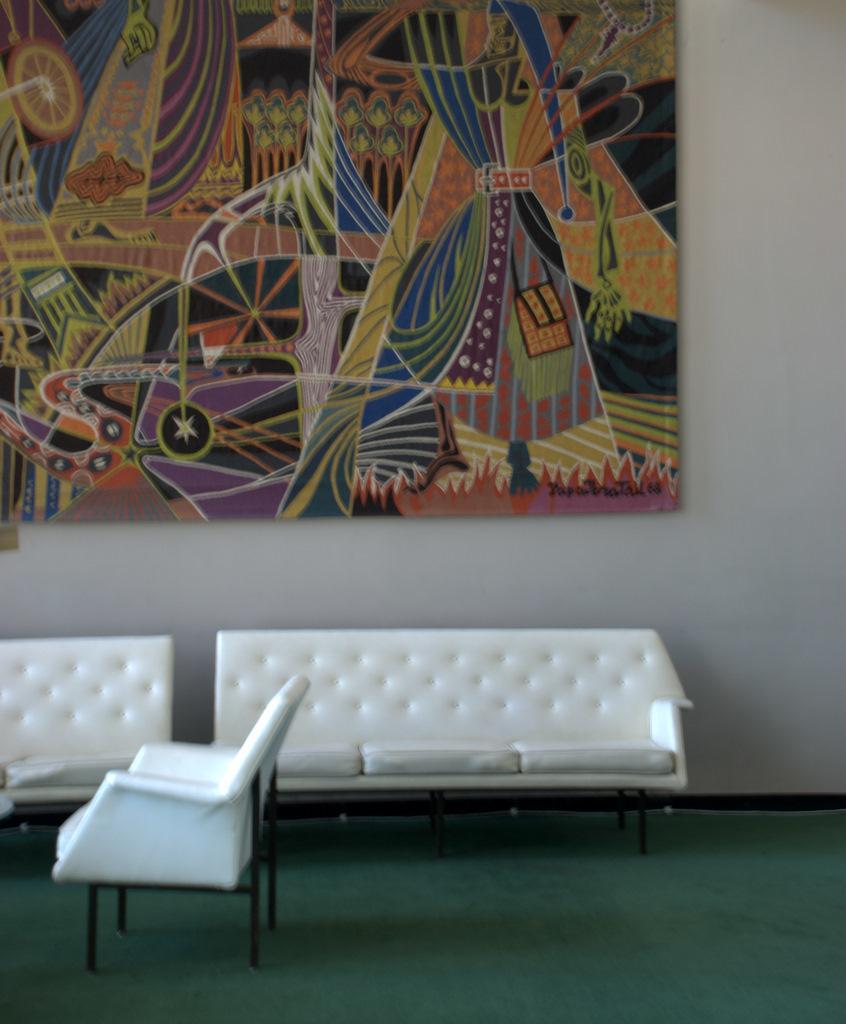Could you give a brief overview of what you see in this image? We can see sofas,chair on the floor. On the background we can see wall,painting board. 